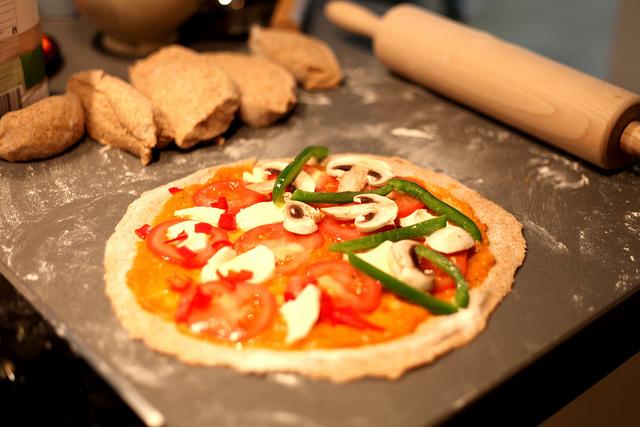What is the wooden item called?
Give a very brief answer. Rolling pin. Are there any vegetables on the pizza?
Keep it brief. Yes. What are they making?
Write a very short answer. Pizza. 